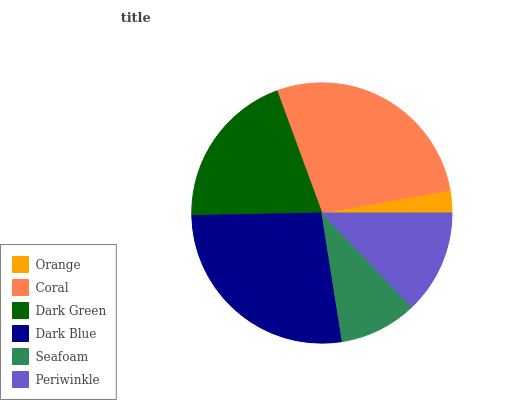Is Orange the minimum?
Answer yes or no. Yes. Is Coral the maximum?
Answer yes or no. Yes. Is Dark Green the minimum?
Answer yes or no. No. Is Dark Green the maximum?
Answer yes or no. No. Is Coral greater than Dark Green?
Answer yes or no. Yes. Is Dark Green less than Coral?
Answer yes or no. Yes. Is Dark Green greater than Coral?
Answer yes or no. No. Is Coral less than Dark Green?
Answer yes or no. No. Is Dark Green the high median?
Answer yes or no. Yes. Is Periwinkle the low median?
Answer yes or no. Yes. Is Orange the high median?
Answer yes or no. No. Is Orange the low median?
Answer yes or no. No. 